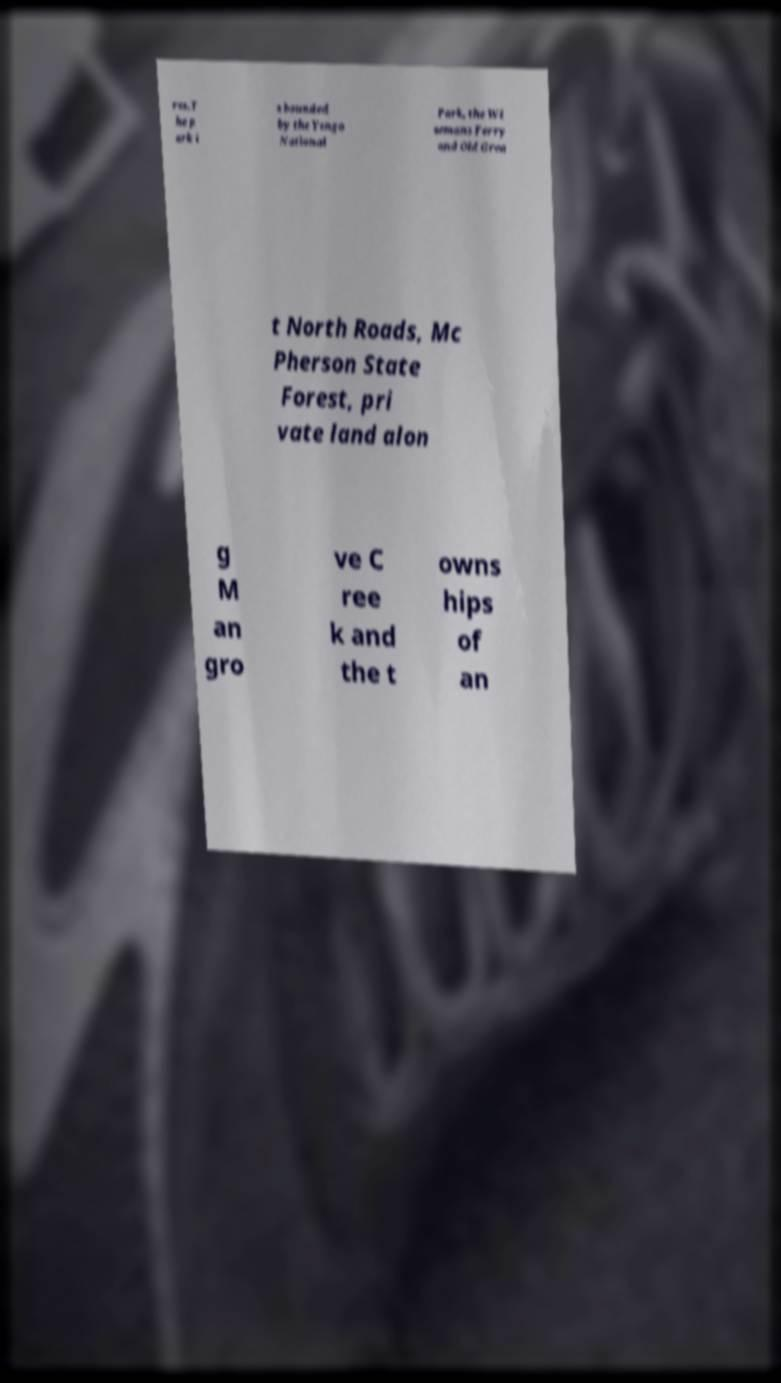Please read and relay the text visible in this image. What does it say? res.T he p ark i s bounded by the Yengo National Park, the Wi semans Ferry and Old Grea t North Roads, Mc Pherson State Forest, pri vate land alon g M an gro ve C ree k and the t owns hips of an 